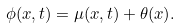<formula> <loc_0><loc_0><loc_500><loc_500>\phi ( x , t ) = \mu ( x , t ) + \theta ( x ) .</formula> 